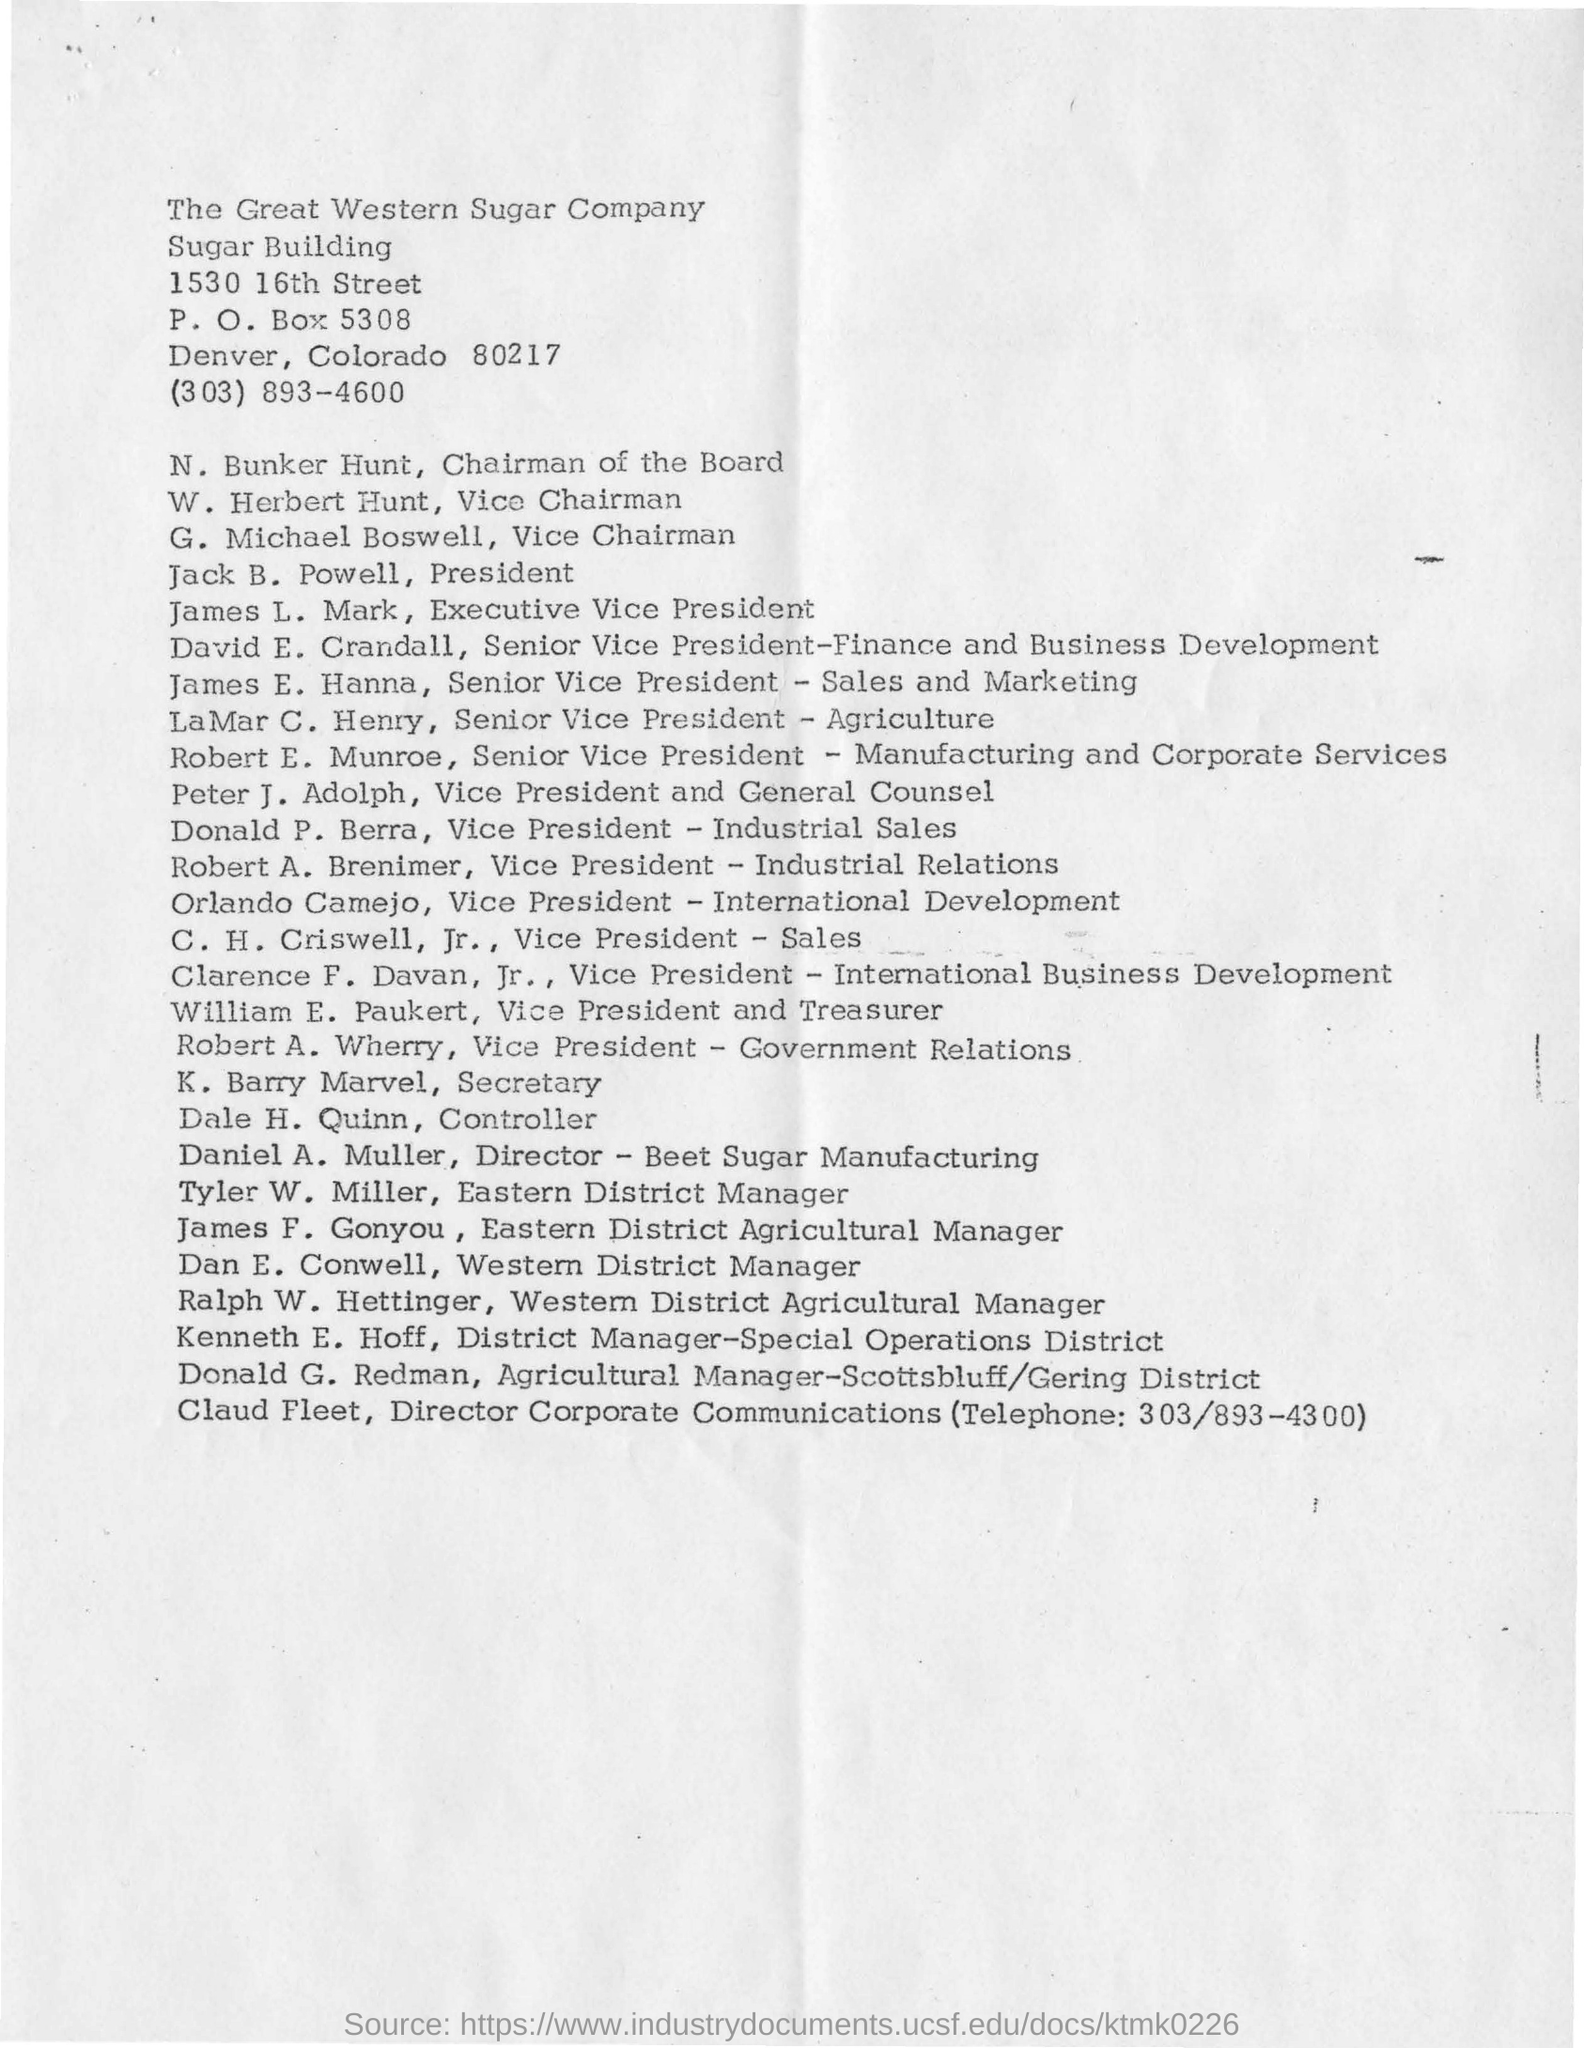Specify some key components in this picture. The telephone number for the Director of Corporate Communications is (303) 893-4300. N. Bunker Hunt is the Chairman of the designation. The Senior Vice President of Sales and Marketing is named James E. Hanna. Daniel A. Muller is the Director of Beet Sugar Manufacturing. The Great Western Sugar Company is situated in Denver, a city known for its industrial and economic prowess. 